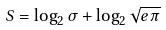Convert formula to latex. <formula><loc_0><loc_0><loc_500><loc_500>S = \log _ { 2 } \sigma + \log _ { 2 } \sqrt { e \pi }</formula> 